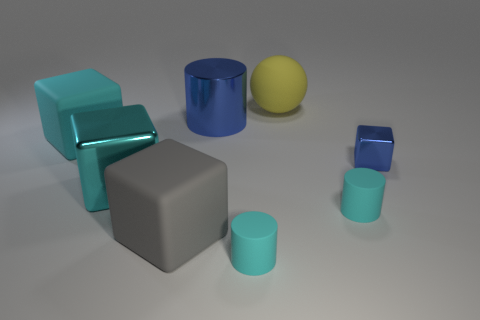The blue thing that is the same shape as the big gray object is what size?
Give a very brief answer. Small. What material is the cylinder that is the same color as the small metallic cube?
Provide a short and direct response. Metal. Is there a sphere of the same size as the blue metal cylinder?
Keep it short and to the point. Yes. There is a tiny blue thing that is the same shape as the large gray thing; what material is it?
Provide a short and direct response. Metal. There is a gray rubber object that is the same size as the yellow sphere; what is its shape?
Keep it short and to the point. Cube. Are there any blue objects of the same shape as the yellow thing?
Give a very brief answer. No. What is the shape of the small matte thing that is on the right side of the tiny cyan matte thing that is on the left side of the yellow rubber ball?
Your answer should be very brief. Cylinder. There is a big cyan metallic thing; what shape is it?
Provide a succinct answer. Cube. What material is the thing in front of the matte cube on the right side of the cyan matte object to the left of the gray rubber cube?
Your response must be concise. Rubber. How many other things are there of the same material as the large ball?
Provide a short and direct response. 4. 